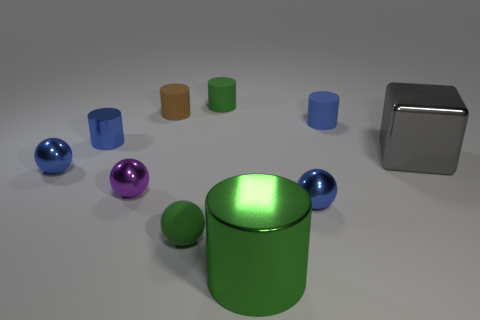There is a small matte cylinder to the right of the large metallic cylinder; is it the same color as the block?
Give a very brief answer. No. What is the size of the blue metallic ball right of the matte sphere?
Ensure brevity in your answer.  Small. What shape is the big thing that is in front of the tiny purple thing left of the large green metallic object?
Give a very brief answer. Cylinder. The large metallic thing that is the same shape as the brown rubber thing is what color?
Offer a very short reply. Green. Is the size of the green rubber thing that is in front of the shiny block the same as the purple metallic sphere?
Offer a terse response. Yes. The metallic object that is the same color as the tiny rubber ball is what shape?
Keep it short and to the point. Cylinder. What number of tiny blue balls have the same material as the big gray cube?
Your answer should be very brief. 2. There is a green thing on the right side of the small green matte object to the right of the tiny green thing that is in front of the large gray object; what is it made of?
Ensure brevity in your answer.  Metal. There is a rubber object on the right side of the blue metallic thing to the right of the tiny purple metal object; what is its color?
Your answer should be compact. Blue. What color is the shiny object that is the same size as the cube?
Provide a short and direct response. Green. 